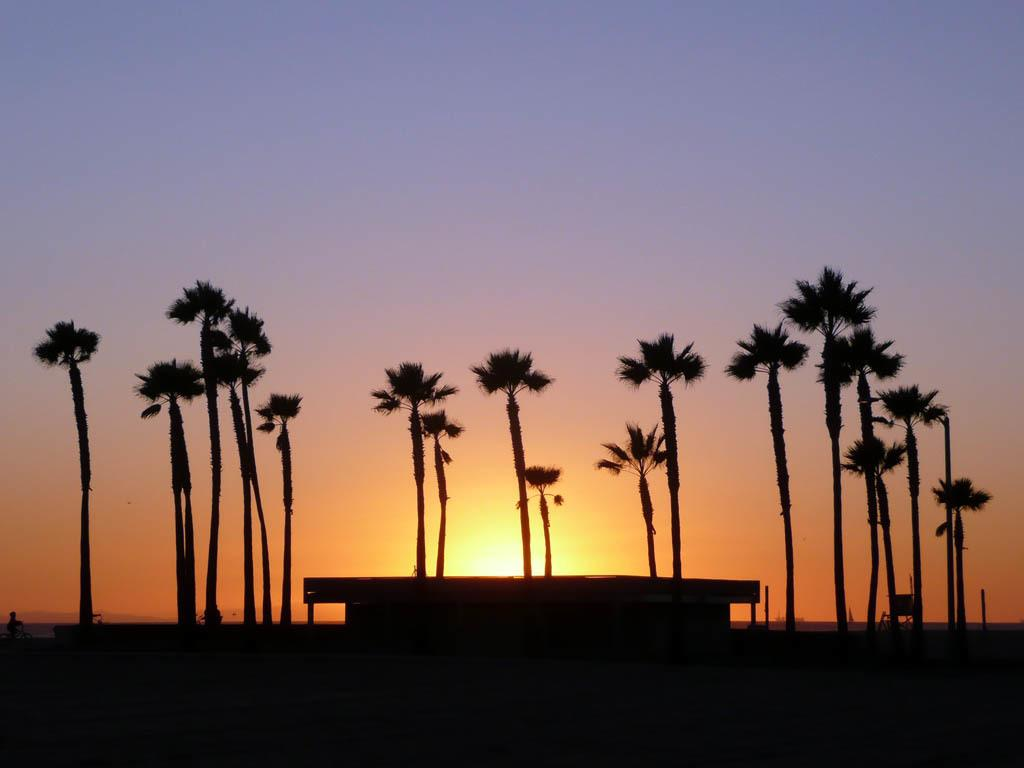What time of day is depicted in the image? The image was taken during the evening time. What type of structure can be seen in the image? There is a building in the image. What other natural elements are present in the image? There are trees in the image. What can be seen in the background of the image? The sky is visible in the background of the image. Can the sun be seen in the image? Yes, the sun is observable in the sky. What type of button can be seen on the building in the image? There is no button present on the building in the image. How does the poison affect the trees in the image? There is no mention of poison in the image, and the trees appear to be healthy. 